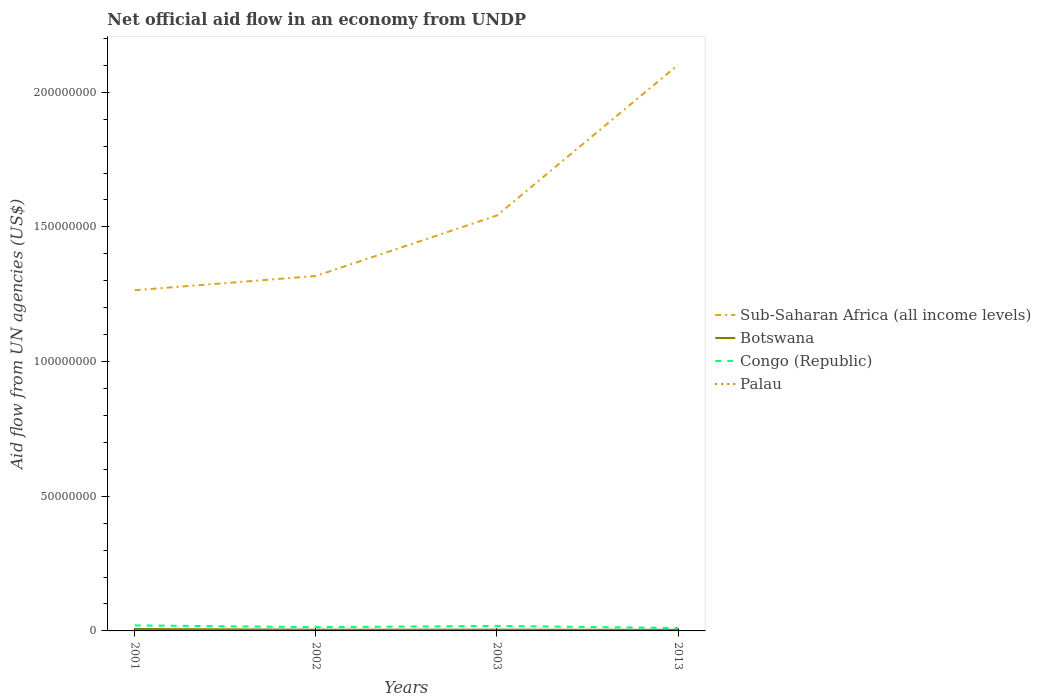How many different coloured lines are there?
Offer a very short reply. 4. Across all years, what is the maximum net official aid flow in Botswana?
Your answer should be compact. 4.10e+05. In which year was the net official aid flow in Congo (Republic) maximum?
Your answer should be compact. 2013. What is the total net official aid flow in Congo (Republic) in the graph?
Offer a very short reply. 7.80e+05. How many lines are there?
Ensure brevity in your answer.  4. Where does the legend appear in the graph?
Make the answer very short. Center right. How are the legend labels stacked?
Your answer should be compact. Vertical. What is the title of the graph?
Provide a short and direct response. Net official aid flow in an economy from UNDP. Does "Czech Republic" appear as one of the legend labels in the graph?
Your answer should be compact. No. What is the label or title of the X-axis?
Make the answer very short. Years. What is the label or title of the Y-axis?
Keep it short and to the point. Aid flow from UN agencies (US$). What is the Aid flow from UN agencies (US$) in Sub-Saharan Africa (all income levels) in 2001?
Your answer should be very brief. 1.26e+08. What is the Aid flow from UN agencies (US$) of Botswana in 2001?
Your answer should be very brief. 7.20e+05. What is the Aid flow from UN agencies (US$) of Congo (Republic) in 2001?
Make the answer very short. 2.06e+06. What is the Aid flow from UN agencies (US$) of Sub-Saharan Africa (all income levels) in 2002?
Offer a very short reply. 1.32e+08. What is the Aid flow from UN agencies (US$) in Congo (Republic) in 2002?
Offer a very short reply. 1.39e+06. What is the Aid flow from UN agencies (US$) in Sub-Saharan Africa (all income levels) in 2003?
Offer a very short reply. 1.54e+08. What is the Aid flow from UN agencies (US$) in Congo (Republic) in 2003?
Ensure brevity in your answer.  1.86e+06. What is the Aid flow from UN agencies (US$) of Palau in 2003?
Offer a very short reply. 10000. What is the Aid flow from UN agencies (US$) of Sub-Saharan Africa (all income levels) in 2013?
Your answer should be very brief. 2.10e+08. What is the Aid flow from UN agencies (US$) in Congo (Republic) in 2013?
Offer a very short reply. 1.08e+06. What is the Aid flow from UN agencies (US$) in Palau in 2013?
Provide a succinct answer. 2.00e+04. Across all years, what is the maximum Aid flow from UN agencies (US$) in Sub-Saharan Africa (all income levels)?
Keep it short and to the point. 2.10e+08. Across all years, what is the maximum Aid flow from UN agencies (US$) of Botswana?
Keep it short and to the point. 7.20e+05. Across all years, what is the maximum Aid flow from UN agencies (US$) of Congo (Republic)?
Your response must be concise. 2.06e+06. Across all years, what is the minimum Aid flow from UN agencies (US$) in Sub-Saharan Africa (all income levels)?
Offer a terse response. 1.26e+08. Across all years, what is the minimum Aid flow from UN agencies (US$) in Congo (Republic)?
Ensure brevity in your answer.  1.08e+06. Across all years, what is the minimum Aid flow from UN agencies (US$) in Palau?
Ensure brevity in your answer.  10000. What is the total Aid flow from UN agencies (US$) in Sub-Saharan Africa (all income levels) in the graph?
Provide a succinct answer. 6.23e+08. What is the total Aid flow from UN agencies (US$) of Botswana in the graph?
Offer a very short reply. 2.08e+06. What is the total Aid flow from UN agencies (US$) of Congo (Republic) in the graph?
Your response must be concise. 6.39e+06. What is the total Aid flow from UN agencies (US$) of Palau in the graph?
Your answer should be compact. 1.30e+05. What is the difference between the Aid flow from UN agencies (US$) in Sub-Saharan Africa (all income levels) in 2001 and that in 2002?
Offer a very short reply. -5.28e+06. What is the difference between the Aid flow from UN agencies (US$) in Congo (Republic) in 2001 and that in 2002?
Your response must be concise. 6.70e+05. What is the difference between the Aid flow from UN agencies (US$) in Sub-Saharan Africa (all income levels) in 2001 and that in 2003?
Your answer should be compact. -2.78e+07. What is the difference between the Aid flow from UN agencies (US$) in Sub-Saharan Africa (all income levels) in 2001 and that in 2013?
Make the answer very short. -8.37e+07. What is the difference between the Aid flow from UN agencies (US$) of Congo (Republic) in 2001 and that in 2013?
Give a very brief answer. 9.80e+05. What is the difference between the Aid flow from UN agencies (US$) in Sub-Saharan Africa (all income levels) in 2002 and that in 2003?
Provide a short and direct response. -2.25e+07. What is the difference between the Aid flow from UN agencies (US$) of Botswana in 2002 and that in 2003?
Your response must be concise. -10000. What is the difference between the Aid flow from UN agencies (US$) of Congo (Republic) in 2002 and that in 2003?
Your answer should be very brief. -4.70e+05. What is the difference between the Aid flow from UN agencies (US$) in Palau in 2002 and that in 2003?
Your answer should be very brief. 8.00e+04. What is the difference between the Aid flow from UN agencies (US$) in Sub-Saharan Africa (all income levels) in 2002 and that in 2013?
Ensure brevity in your answer.  -7.84e+07. What is the difference between the Aid flow from UN agencies (US$) of Congo (Republic) in 2002 and that in 2013?
Provide a succinct answer. 3.10e+05. What is the difference between the Aid flow from UN agencies (US$) of Palau in 2002 and that in 2013?
Provide a succinct answer. 7.00e+04. What is the difference between the Aid flow from UN agencies (US$) of Sub-Saharan Africa (all income levels) in 2003 and that in 2013?
Keep it short and to the point. -5.59e+07. What is the difference between the Aid flow from UN agencies (US$) of Congo (Republic) in 2003 and that in 2013?
Offer a terse response. 7.80e+05. What is the difference between the Aid flow from UN agencies (US$) in Sub-Saharan Africa (all income levels) in 2001 and the Aid flow from UN agencies (US$) in Botswana in 2002?
Your response must be concise. 1.26e+08. What is the difference between the Aid flow from UN agencies (US$) of Sub-Saharan Africa (all income levels) in 2001 and the Aid flow from UN agencies (US$) of Congo (Republic) in 2002?
Your answer should be compact. 1.25e+08. What is the difference between the Aid flow from UN agencies (US$) of Sub-Saharan Africa (all income levels) in 2001 and the Aid flow from UN agencies (US$) of Palau in 2002?
Provide a short and direct response. 1.26e+08. What is the difference between the Aid flow from UN agencies (US$) in Botswana in 2001 and the Aid flow from UN agencies (US$) in Congo (Republic) in 2002?
Your answer should be very brief. -6.70e+05. What is the difference between the Aid flow from UN agencies (US$) in Botswana in 2001 and the Aid flow from UN agencies (US$) in Palau in 2002?
Provide a short and direct response. 6.30e+05. What is the difference between the Aid flow from UN agencies (US$) in Congo (Republic) in 2001 and the Aid flow from UN agencies (US$) in Palau in 2002?
Keep it short and to the point. 1.97e+06. What is the difference between the Aid flow from UN agencies (US$) of Sub-Saharan Africa (all income levels) in 2001 and the Aid flow from UN agencies (US$) of Botswana in 2003?
Your answer should be very brief. 1.26e+08. What is the difference between the Aid flow from UN agencies (US$) of Sub-Saharan Africa (all income levels) in 2001 and the Aid flow from UN agencies (US$) of Congo (Republic) in 2003?
Provide a succinct answer. 1.25e+08. What is the difference between the Aid flow from UN agencies (US$) of Sub-Saharan Africa (all income levels) in 2001 and the Aid flow from UN agencies (US$) of Palau in 2003?
Ensure brevity in your answer.  1.26e+08. What is the difference between the Aid flow from UN agencies (US$) of Botswana in 2001 and the Aid flow from UN agencies (US$) of Congo (Republic) in 2003?
Ensure brevity in your answer.  -1.14e+06. What is the difference between the Aid flow from UN agencies (US$) of Botswana in 2001 and the Aid flow from UN agencies (US$) of Palau in 2003?
Your response must be concise. 7.10e+05. What is the difference between the Aid flow from UN agencies (US$) in Congo (Republic) in 2001 and the Aid flow from UN agencies (US$) in Palau in 2003?
Ensure brevity in your answer.  2.05e+06. What is the difference between the Aid flow from UN agencies (US$) of Sub-Saharan Africa (all income levels) in 2001 and the Aid flow from UN agencies (US$) of Botswana in 2013?
Your answer should be compact. 1.26e+08. What is the difference between the Aid flow from UN agencies (US$) of Sub-Saharan Africa (all income levels) in 2001 and the Aid flow from UN agencies (US$) of Congo (Republic) in 2013?
Ensure brevity in your answer.  1.25e+08. What is the difference between the Aid flow from UN agencies (US$) of Sub-Saharan Africa (all income levels) in 2001 and the Aid flow from UN agencies (US$) of Palau in 2013?
Ensure brevity in your answer.  1.26e+08. What is the difference between the Aid flow from UN agencies (US$) in Botswana in 2001 and the Aid flow from UN agencies (US$) in Congo (Republic) in 2013?
Offer a terse response. -3.60e+05. What is the difference between the Aid flow from UN agencies (US$) in Congo (Republic) in 2001 and the Aid flow from UN agencies (US$) in Palau in 2013?
Make the answer very short. 2.04e+06. What is the difference between the Aid flow from UN agencies (US$) of Sub-Saharan Africa (all income levels) in 2002 and the Aid flow from UN agencies (US$) of Botswana in 2003?
Offer a terse response. 1.31e+08. What is the difference between the Aid flow from UN agencies (US$) of Sub-Saharan Africa (all income levels) in 2002 and the Aid flow from UN agencies (US$) of Congo (Republic) in 2003?
Your answer should be compact. 1.30e+08. What is the difference between the Aid flow from UN agencies (US$) of Sub-Saharan Africa (all income levels) in 2002 and the Aid flow from UN agencies (US$) of Palau in 2003?
Ensure brevity in your answer.  1.32e+08. What is the difference between the Aid flow from UN agencies (US$) of Botswana in 2002 and the Aid flow from UN agencies (US$) of Congo (Republic) in 2003?
Provide a short and direct response. -1.39e+06. What is the difference between the Aid flow from UN agencies (US$) of Congo (Republic) in 2002 and the Aid flow from UN agencies (US$) of Palau in 2003?
Your response must be concise. 1.38e+06. What is the difference between the Aid flow from UN agencies (US$) in Sub-Saharan Africa (all income levels) in 2002 and the Aid flow from UN agencies (US$) in Botswana in 2013?
Provide a succinct answer. 1.31e+08. What is the difference between the Aid flow from UN agencies (US$) of Sub-Saharan Africa (all income levels) in 2002 and the Aid flow from UN agencies (US$) of Congo (Republic) in 2013?
Keep it short and to the point. 1.31e+08. What is the difference between the Aid flow from UN agencies (US$) of Sub-Saharan Africa (all income levels) in 2002 and the Aid flow from UN agencies (US$) of Palau in 2013?
Give a very brief answer. 1.32e+08. What is the difference between the Aid flow from UN agencies (US$) in Botswana in 2002 and the Aid flow from UN agencies (US$) in Congo (Republic) in 2013?
Offer a very short reply. -6.10e+05. What is the difference between the Aid flow from UN agencies (US$) in Botswana in 2002 and the Aid flow from UN agencies (US$) in Palau in 2013?
Your response must be concise. 4.50e+05. What is the difference between the Aid flow from UN agencies (US$) of Congo (Republic) in 2002 and the Aid flow from UN agencies (US$) of Palau in 2013?
Offer a terse response. 1.37e+06. What is the difference between the Aid flow from UN agencies (US$) in Sub-Saharan Africa (all income levels) in 2003 and the Aid flow from UN agencies (US$) in Botswana in 2013?
Your answer should be very brief. 1.54e+08. What is the difference between the Aid flow from UN agencies (US$) of Sub-Saharan Africa (all income levels) in 2003 and the Aid flow from UN agencies (US$) of Congo (Republic) in 2013?
Offer a very short reply. 1.53e+08. What is the difference between the Aid flow from UN agencies (US$) in Sub-Saharan Africa (all income levels) in 2003 and the Aid flow from UN agencies (US$) in Palau in 2013?
Ensure brevity in your answer.  1.54e+08. What is the difference between the Aid flow from UN agencies (US$) in Botswana in 2003 and the Aid flow from UN agencies (US$) in Congo (Republic) in 2013?
Offer a terse response. -6.00e+05. What is the difference between the Aid flow from UN agencies (US$) in Botswana in 2003 and the Aid flow from UN agencies (US$) in Palau in 2013?
Give a very brief answer. 4.60e+05. What is the difference between the Aid flow from UN agencies (US$) in Congo (Republic) in 2003 and the Aid flow from UN agencies (US$) in Palau in 2013?
Offer a very short reply. 1.84e+06. What is the average Aid flow from UN agencies (US$) in Sub-Saharan Africa (all income levels) per year?
Offer a very short reply. 1.56e+08. What is the average Aid flow from UN agencies (US$) in Botswana per year?
Make the answer very short. 5.20e+05. What is the average Aid flow from UN agencies (US$) in Congo (Republic) per year?
Provide a short and direct response. 1.60e+06. What is the average Aid flow from UN agencies (US$) of Palau per year?
Your response must be concise. 3.25e+04. In the year 2001, what is the difference between the Aid flow from UN agencies (US$) in Sub-Saharan Africa (all income levels) and Aid flow from UN agencies (US$) in Botswana?
Your answer should be very brief. 1.26e+08. In the year 2001, what is the difference between the Aid flow from UN agencies (US$) of Sub-Saharan Africa (all income levels) and Aid flow from UN agencies (US$) of Congo (Republic)?
Provide a succinct answer. 1.24e+08. In the year 2001, what is the difference between the Aid flow from UN agencies (US$) in Sub-Saharan Africa (all income levels) and Aid flow from UN agencies (US$) in Palau?
Ensure brevity in your answer.  1.26e+08. In the year 2001, what is the difference between the Aid flow from UN agencies (US$) in Botswana and Aid flow from UN agencies (US$) in Congo (Republic)?
Provide a short and direct response. -1.34e+06. In the year 2001, what is the difference between the Aid flow from UN agencies (US$) of Botswana and Aid flow from UN agencies (US$) of Palau?
Your response must be concise. 7.10e+05. In the year 2001, what is the difference between the Aid flow from UN agencies (US$) of Congo (Republic) and Aid flow from UN agencies (US$) of Palau?
Ensure brevity in your answer.  2.05e+06. In the year 2002, what is the difference between the Aid flow from UN agencies (US$) in Sub-Saharan Africa (all income levels) and Aid flow from UN agencies (US$) in Botswana?
Provide a succinct answer. 1.31e+08. In the year 2002, what is the difference between the Aid flow from UN agencies (US$) of Sub-Saharan Africa (all income levels) and Aid flow from UN agencies (US$) of Congo (Republic)?
Provide a short and direct response. 1.30e+08. In the year 2002, what is the difference between the Aid flow from UN agencies (US$) of Sub-Saharan Africa (all income levels) and Aid flow from UN agencies (US$) of Palau?
Offer a very short reply. 1.32e+08. In the year 2002, what is the difference between the Aid flow from UN agencies (US$) in Botswana and Aid flow from UN agencies (US$) in Congo (Republic)?
Your answer should be very brief. -9.20e+05. In the year 2002, what is the difference between the Aid flow from UN agencies (US$) in Congo (Republic) and Aid flow from UN agencies (US$) in Palau?
Your answer should be very brief. 1.30e+06. In the year 2003, what is the difference between the Aid flow from UN agencies (US$) in Sub-Saharan Africa (all income levels) and Aid flow from UN agencies (US$) in Botswana?
Keep it short and to the point. 1.54e+08. In the year 2003, what is the difference between the Aid flow from UN agencies (US$) of Sub-Saharan Africa (all income levels) and Aid flow from UN agencies (US$) of Congo (Republic)?
Provide a short and direct response. 1.52e+08. In the year 2003, what is the difference between the Aid flow from UN agencies (US$) in Sub-Saharan Africa (all income levels) and Aid flow from UN agencies (US$) in Palau?
Your answer should be very brief. 1.54e+08. In the year 2003, what is the difference between the Aid flow from UN agencies (US$) in Botswana and Aid flow from UN agencies (US$) in Congo (Republic)?
Keep it short and to the point. -1.38e+06. In the year 2003, what is the difference between the Aid flow from UN agencies (US$) in Botswana and Aid flow from UN agencies (US$) in Palau?
Keep it short and to the point. 4.70e+05. In the year 2003, what is the difference between the Aid flow from UN agencies (US$) in Congo (Republic) and Aid flow from UN agencies (US$) in Palau?
Your answer should be compact. 1.85e+06. In the year 2013, what is the difference between the Aid flow from UN agencies (US$) in Sub-Saharan Africa (all income levels) and Aid flow from UN agencies (US$) in Botswana?
Provide a short and direct response. 2.10e+08. In the year 2013, what is the difference between the Aid flow from UN agencies (US$) of Sub-Saharan Africa (all income levels) and Aid flow from UN agencies (US$) of Congo (Republic)?
Offer a very short reply. 2.09e+08. In the year 2013, what is the difference between the Aid flow from UN agencies (US$) in Sub-Saharan Africa (all income levels) and Aid flow from UN agencies (US$) in Palau?
Provide a short and direct response. 2.10e+08. In the year 2013, what is the difference between the Aid flow from UN agencies (US$) in Botswana and Aid flow from UN agencies (US$) in Congo (Republic)?
Your answer should be compact. -6.70e+05. In the year 2013, what is the difference between the Aid flow from UN agencies (US$) of Congo (Republic) and Aid flow from UN agencies (US$) of Palau?
Ensure brevity in your answer.  1.06e+06. What is the ratio of the Aid flow from UN agencies (US$) in Sub-Saharan Africa (all income levels) in 2001 to that in 2002?
Your answer should be very brief. 0.96. What is the ratio of the Aid flow from UN agencies (US$) of Botswana in 2001 to that in 2002?
Your response must be concise. 1.53. What is the ratio of the Aid flow from UN agencies (US$) of Congo (Republic) in 2001 to that in 2002?
Provide a short and direct response. 1.48. What is the ratio of the Aid flow from UN agencies (US$) in Sub-Saharan Africa (all income levels) in 2001 to that in 2003?
Your answer should be very brief. 0.82. What is the ratio of the Aid flow from UN agencies (US$) in Congo (Republic) in 2001 to that in 2003?
Keep it short and to the point. 1.11. What is the ratio of the Aid flow from UN agencies (US$) of Sub-Saharan Africa (all income levels) in 2001 to that in 2013?
Provide a short and direct response. 0.6. What is the ratio of the Aid flow from UN agencies (US$) in Botswana in 2001 to that in 2013?
Ensure brevity in your answer.  1.76. What is the ratio of the Aid flow from UN agencies (US$) of Congo (Republic) in 2001 to that in 2013?
Ensure brevity in your answer.  1.91. What is the ratio of the Aid flow from UN agencies (US$) of Sub-Saharan Africa (all income levels) in 2002 to that in 2003?
Your answer should be compact. 0.85. What is the ratio of the Aid flow from UN agencies (US$) of Botswana in 2002 to that in 2003?
Offer a terse response. 0.98. What is the ratio of the Aid flow from UN agencies (US$) in Congo (Republic) in 2002 to that in 2003?
Your answer should be very brief. 0.75. What is the ratio of the Aid flow from UN agencies (US$) of Palau in 2002 to that in 2003?
Your answer should be very brief. 9. What is the ratio of the Aid flow from UN agencies (US$) of Sub-Saharan Africa (all income levels) in 2002 to that in 2013?
Make the answer very short. 0.63. What is the ratio of the Aid flow from UN agencies (US$) in Botswana in 2002 to that in 2013?
Keep it short and to the point. 1.15. What is the ratio of the Aid flow from UN agencies (US$) of Congo (Republic) in 2002 to that in 2013?
Make the answer very short. 1.29. What is the ratio of the Aid flow from UN agencies (US$) in Palau in 2002 to that in 2013?
Provide a succinct answer. 4.5. What is the ratio of the Aid flow from UN agencies (US$) of Sub-Saharan Africa (all income levels) in 2003 to that in 2013?
Offer a very short reply. 0.73. What is the ratio of the Aid flow from UN agencies (US$) of Botswana in 2003 to that in 2013?
Keep it short and to the point. 1.17. What is the ratio of the Aid flow from UN agencies (US$) in Congo (Republic) in 2003 to that in 2013?
Keep it short and to the point. 1.72. What is the difference between the highest and the second highest Aid flow from UN agencies (US$) of Sub-Saharan Africa (all income levels)?
Provide a short and direct response. 5.59e+07. What is the difference between the highest and the second highest Aid flow from UN agencies (US$) in Palau?
Your answer should be compact. 7.00e+04. What is the difference between the highest and the lowest Aid flow from UN agencies (US$) of Sub-Saharan Africa (all income levels)?
Ensure brevity in your answer.  8.37e+07. What is the difference between the highest and the lowest Aid flow from UN agencies (US$) of Congo (Republic)?
Your response must be concise. 9.80e+05. What is the difference between the highest and the lowest Aid flow from UN agencies (US$) in Palau?
Offer a terse response. 8.00e+04. 